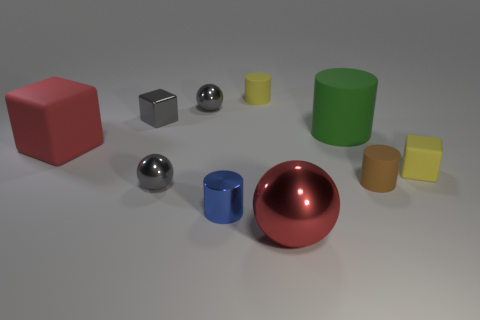Subtract all gray spheres. How many were subtracted if there are1gray spheres left? 1 Subtract all tiny shiny balls. How many balls are left? 1 Subtract all green cylinders. How many gray spheres are left? 2 Subtract all red spheres. How many spheres are left? 2 Subtract 2 cubes. How many cubes are left? 1 Subtract all cylinders. How many objects are left? 6 Subtract 1 green cylinders. How many objects are left? 9 Subtract all blue spheres. Subtract all purple cubes. How many spheres are left? 3 Subtract all large red metal balls. Subtract all large green matte things. How many objects are left? 8 Add 1 tiny brown rubber objects. How many tiny brown rubber objects are left? 2 